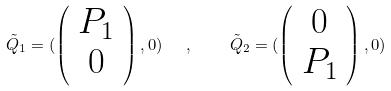Convert formula to latex. <formula><loc_0><loc_0><loc_500><loc_500>\tilde { Q } _ { 1 } = ( \left ( \begin{array} { c } P _ { 1 } \\ 0 \end{array} \right ) , 0 ) \ \ , \quad \tilde { Q } _ { 2 } = ( \left ( \begin{array} { c } 0 \\ P _ { 1 } \end{array} \right ) , 0 )</formula> 